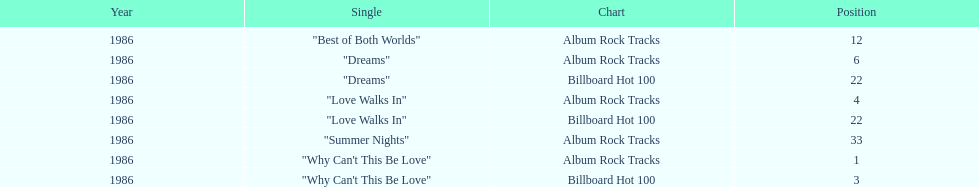Which single on the album is the most favored? Why Can't This Be Love. 